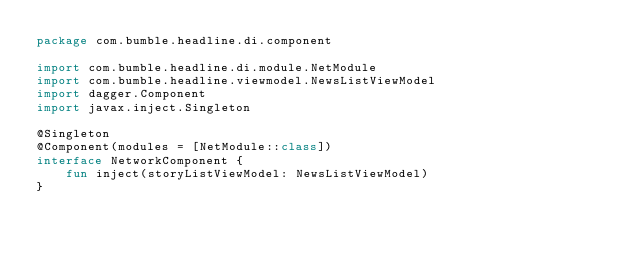<code> <loc_0><loc_0><loc_500><loc_500><_Kotlin_>package com.bumble.headline.di.component

import com.bumble.headline.di.module.NetModule
import com.bumble.headline.viewmodel.NewsListViewModel
import dagger.Component
import javax.inject.Singleton

@Singleton
@Component(modules = [NetModule::class])
interface NetworkComponent {
    fun inject(storyListViewModel: NewsListViewModel)
}</code> 